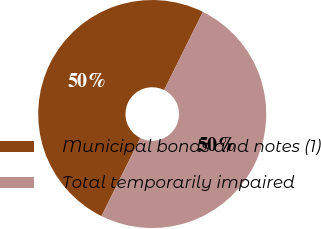Convert chart to OTSL. <chart><loc_0><loc_0><loc_500><loc_500><pie_chart><fcel>Municipal bonds and notes (1)<fcel>Total temporarily impaired<nl><fcel>50.0%<fcel>50.0%<nl></chart> 